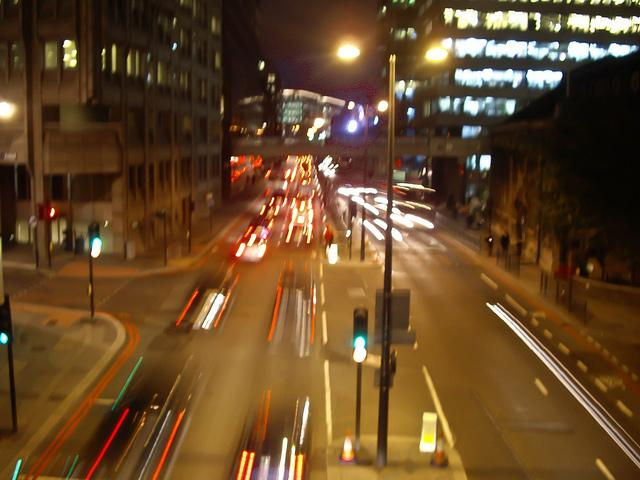What is near the cars?

Choices:
A) hose
B) street lights
C) cow
D) garage clerk street lights 